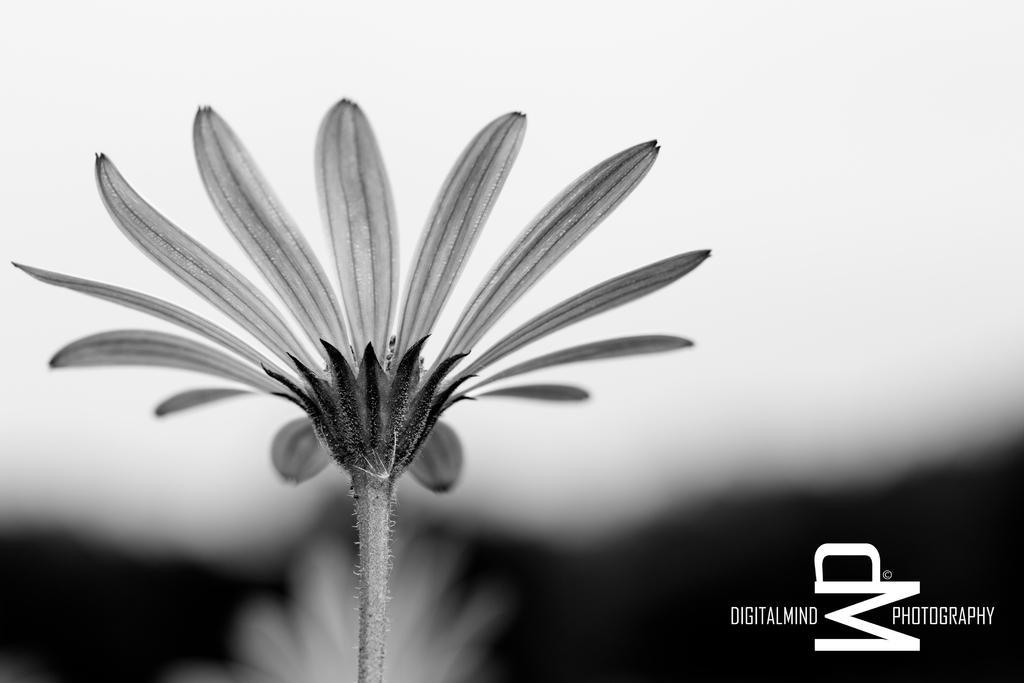Can you describe this image briefly? This is a black and white pic. On the left we can see a flower. In the background the image is blur and on the right at the bottom corner we can see a text. 